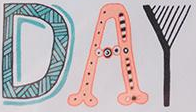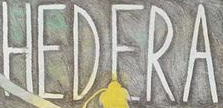Transcribe the words shown in these images in order, separated by a semicolon. DAY; HEDERA 